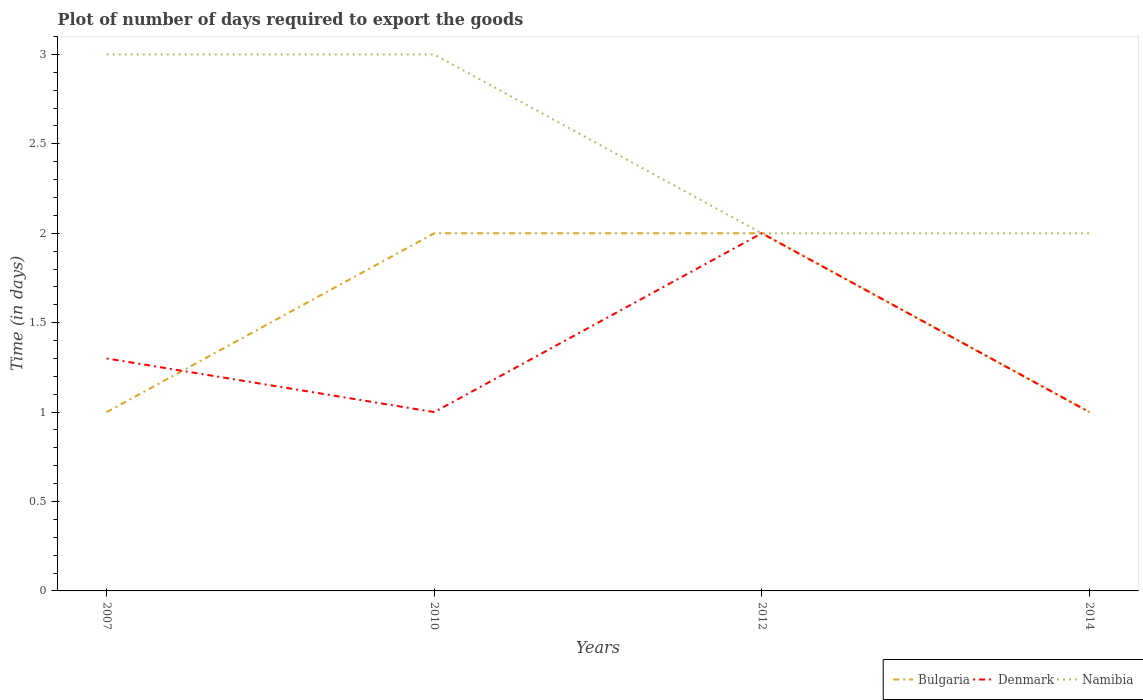Across all years, what is the maximum time required to export goods in Bulgaria?
Ensure brevity in your answer.  1. What is the total time required to export goods in Denmark in the graph?
Your answer should be very brief. 0.3. What is the difference between the highest and the second highest time required to export goods in Denmark?
Give a very brief answer. 1. Is the time required to export goods in Namibia strictly greater than the time required to export goods in Bulgaria over the years?
Give a very brief answer. No. How many lines are there?
Your answer should be very brief. 3. How many years are there in the graph?
Keep it short and to the point. 4. What is the difference between two consecutive major ticks on the Y-axis?
Make the answer very short. 0.5. Where does the legend appear in the graph?
Make the answer very short. Bottom right. How many legend labels are there?
Make the answer very short. 3. What is the title of the graph?
Provide a short and direct response. Plot of number of days required to export the goods. What is the label or title of the Y-axis?
Your answer should be very brief. Time (in days). What is the Time (in days) in Denmark in 2007?
Offer a terse response. 1.3. What is the Time (in days) in Namibia in 2007?
Offer a very short reply. 3. What is the Time (in days) of Namibia in 2010?
Make the answer very short. 3. What is the Time (in days) of Bulgaria in 2012?
Provide a succinct answer. 2. What is the Time (in days) in Namibia in 2012?
Your answer should be very brief. 2. What is the Time (in days) in Bulgaria in 2014?
Make the answer very short. 1. Across all years, what is the maximum Time (in days) of Denmark?
Your response must be concise. 2. Across all years, what is the minimum Time (in days) in Namibia?
Keep it short and to the point. 2. What is the total Time (in days) of Bulgaria in the graph?
Your answer should be compact. 6. What is the total Time (in days) of Denmark in the graph?
Your response must be concise. 5.3. What is the total Time (in days) of Namibia in the graph?
Provide a short and direct response. 10. What is the difference between the Time (in days) of Bulgaria in 2007 and that in 2010?
Your answer should be compact. -1. What is the difference between the Time (in days) of Namibia in 2007 and that in 2010?
Your answer should be very brief. 0. What is the difference between the Time (in days) in Bulgaria in 2007 and that in 2012?
Ensure brevity in your answer.  -1. What is the difference between the Time (in days) in Bulgaria in 2007 and that in 2014?
Provide a succinct answer. 0. What is the difference between the Time (in days) in Bulgaria in 2010 and that in 2012?
Your answer should be very brief. 0. What is the difference between the Time (in days) of Namibia in 2010 and that in 2014?
Your answer should be compact. 1. What is the difference between the Time (in days) of Bulgaria in 2012 and that in 2014?
Provide a succinct answer. 1. What is the difference between the Time (in days) in Namibia in 2012 and that in 2014?
Provide a short and direct response. 0. What is the difference between the Time (in days) in Bulgaria in 2007 and the Time (in days) in Namibia in 2010?
Offer a terse response. -2. What is the difference between the Time (in days) of Denmark in 2007 and the Time (in days) of Namibia in 2010?
Your answer should be very brief. -1.7. What is the difference between the Time (in days) of Bulgaria in 2007 and the Time (in days) of Namibia in 2014?
Offer a very short reply. -1. What is the difference between the Time (in days) of Denmark in 2007 and the Time (in days) of Namibia in 2014?
Provide a short and direct response. -0.7. What is the difference between the Time (in days) of Bulgaria in 2010 and the Time (in days) of Namibia in 2012?
Provide a succinct answer. 0. What is the difference between the Time (in days) in Denmark in 2010 and the Time (in days) in Namibia in 2012?
Keep it short and to the point. -1. What is the difference between the Time (in days) of Bulgaria in 2010 and the Time (in days) of Denmark in 2014?
Provide a short and direct response. 1. What is the difference between the Time (in days) in Denmark in 2010 and the Time (in days) in Namibia in 2014?
Give a very brief answer. -1. What is the difference between the Time (in days) of Denmark in 2012 and the Time (in days) of Namibia in 2014?
Offer a terse response. 0. What is the average Time (in days) in Denmark per year?
Ensure brevity in your answer.  1.32. What is the average Time (in days) in Namibia per year?
Ensure brevity in your answer.  2.5. In the year 2007, what is the difference between the Time (in days) in Bulgaria and Time (in days) in Denmark?
Offer a very short reply. -0.3. In the year 2007, what is the difference between the Time (in days) of Denmark and Time (in days) of Namibia?
Your response must be concise. -1.7. In the year 2014, what is the difference between the Time (in days) of Bulgaria and Time (in days) of Namibia?
Your answer should be very brief. -1. In the year 2014, what is the difference between the Time (in days) of Denmark and Time (in days) of Namibia?
Offer a very short reply. -1. What is the ratio of the Time (in days) of Bulgaria in 2007 to that in 2010?
Give a very brief answer. 0.5. What is the ratio of the Time (in days) in Denmark in 2007 to that in 2012?
Your answer should be very brief. 0.65. What is the ratio of the Time (in days) of Bulgaria in 2007 to that in 2014?
Ensure brevity in your answer.  1. What is the ratio of the Time (in days) of Denmark in 2010 to that in 2012?
Make the answer very short. 0.5. What is the ratio of the Time (in days) of Namibia in 2010 to that in 2014?
Ensure brevity in your answer.  1.5. What is the ratio of the Time (in days) of Namibia in 2012 to that in 2014?
Provide a short and direct response. 1. What is the difference between the highest and the second highest Time (in days) of Bulgaria?
Give a very brief answer. 0. What is the difference between the highest and the second highest Time (in days) of Namibia?
Ensure brevity in your answer.  0. What is the difference between the highest and the lowest Time (in days) in Bulgaria?
Keep it short and to the point. 1. What is the difference between the highest and the lowest Time (in days) of Denmark?
Provide a short and direct response. 1. What is the difference between the highest and the lowest Time (in days) of Namibia?
Ensure brevity in your answer.  1. 